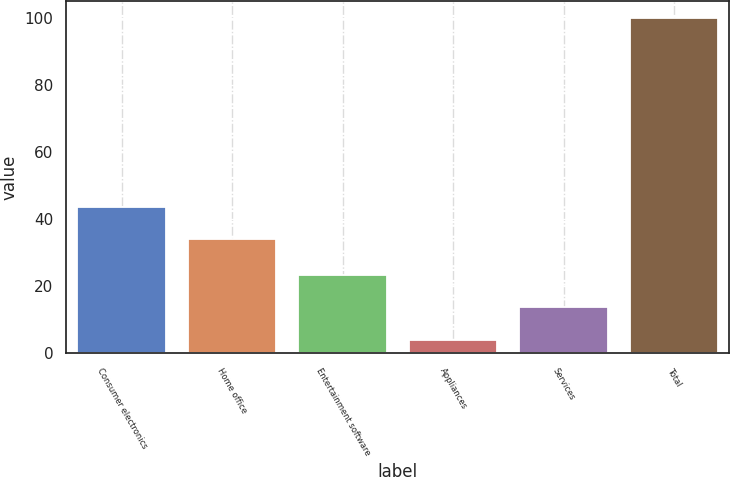Convert chart. <chart><loc_0><loc_0><loc_500><loc_500><bar_chart><fcel>Consumer electronics<fcel>Home office<fcel>Entertainment software<fcel>Appliances<fcel>Services<fcel>Total<nl><fcel>43.6<fcel>34<fcel>23.2<fcel>4<fcel>13.6<fcel>100<nl></chart> 